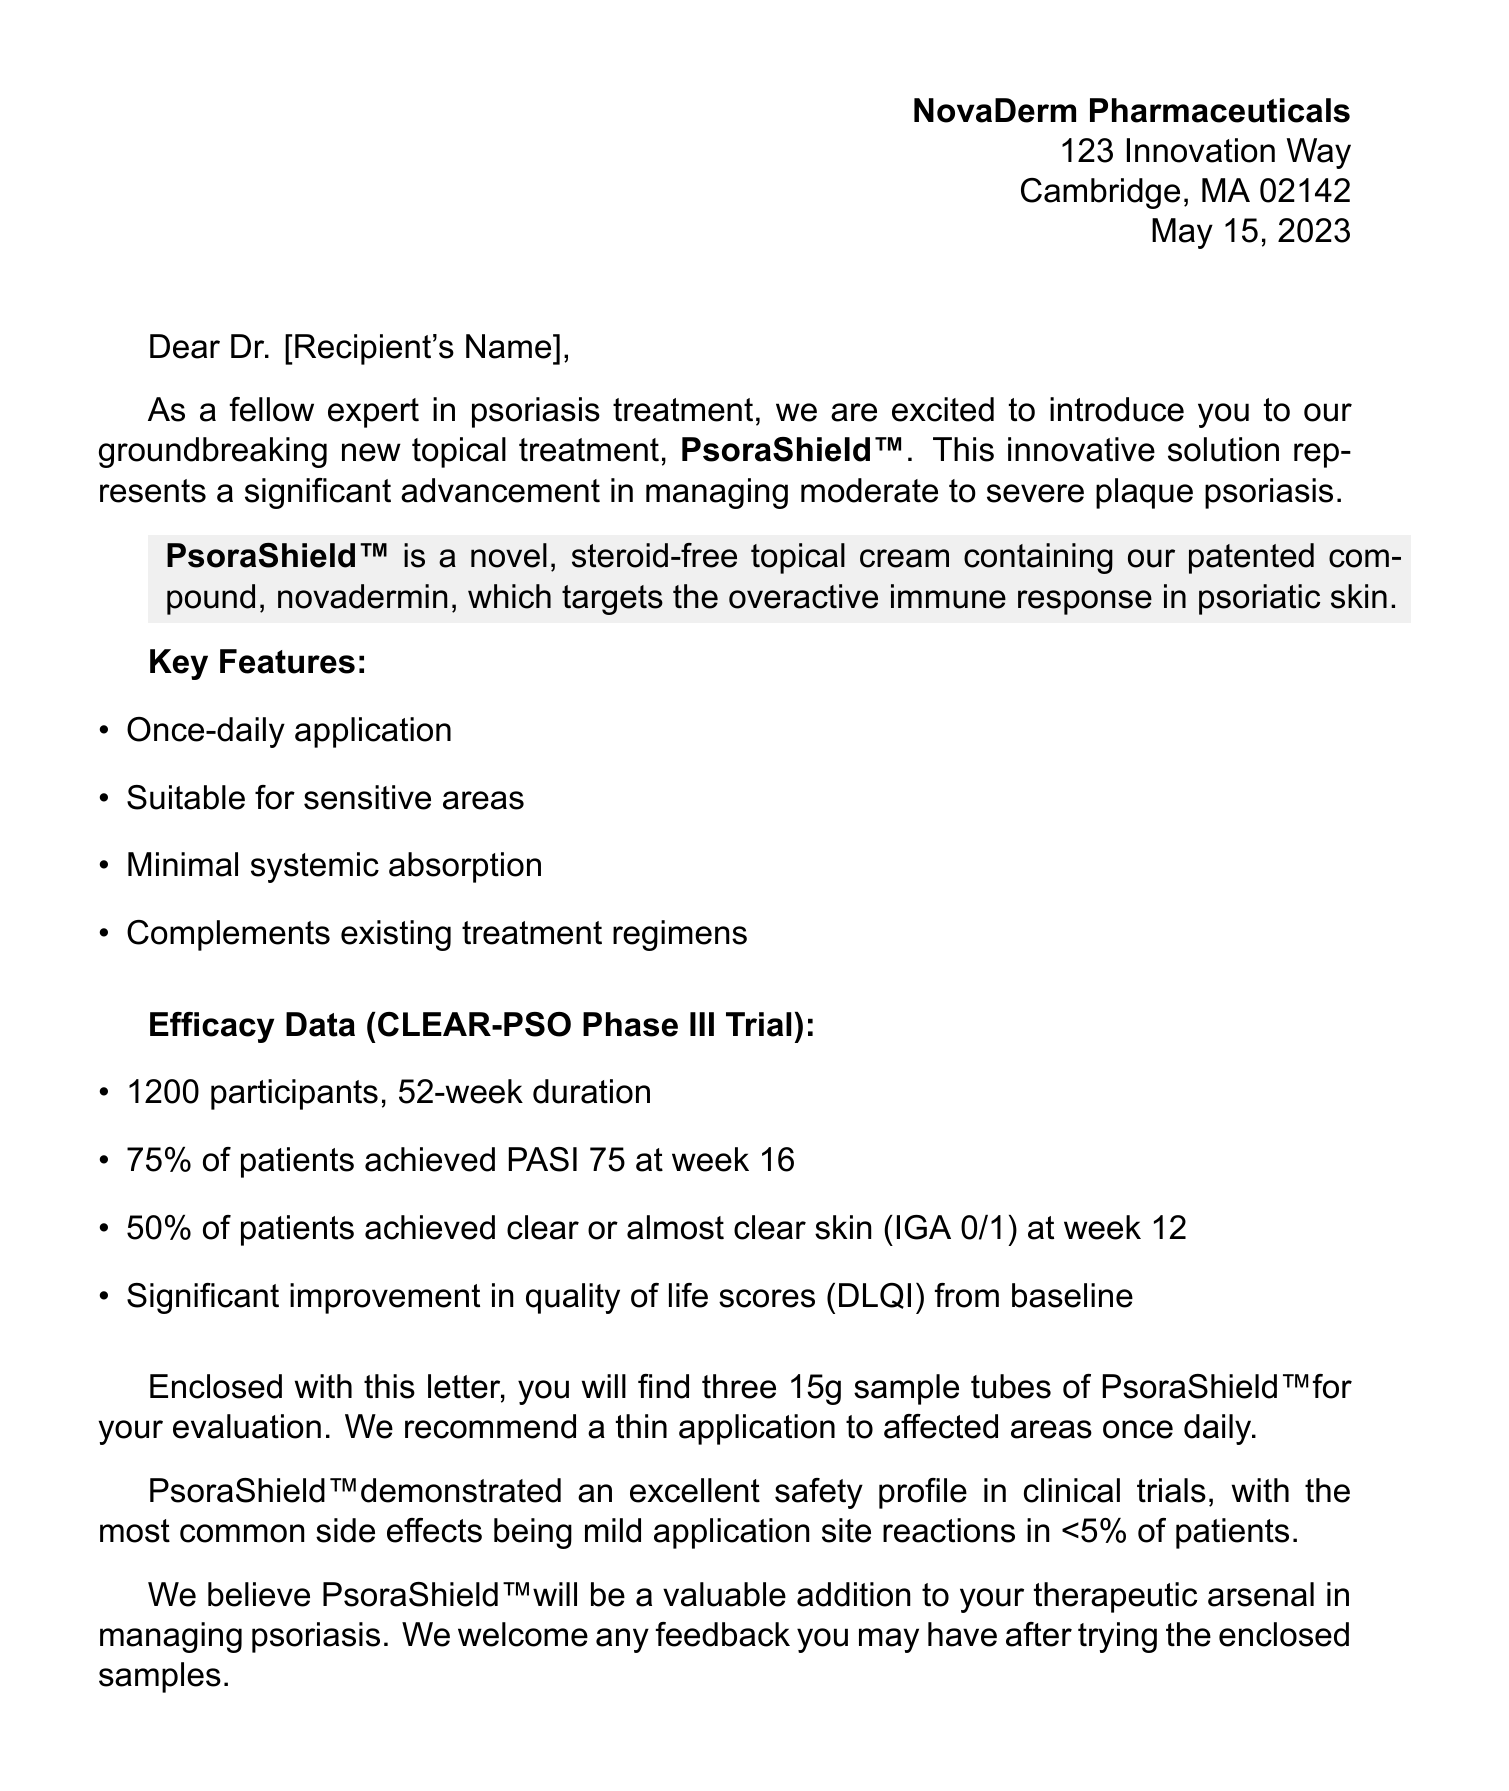what is the name of the new treatment for psoriasis? The name of the new treatment mentioned in the letter is PsoraShield™.
Answer: PsoraShield™ who is the Chief Medical Officer of NovaDerm Pharmaceuticals? According to the document, the Chief Medical Officer is Dr. Emily Chen.
Answer: Dr. Emily Chen how many participants were in the CLEAR-PSO Phase III Trial? The trial involved 1200 participants, as stated in the efficacy data section.
Answer: 1200 what is the recommended application frequency for PsoraShield™? The letter recommends a once-daily application of PsoraShield™.
Answer: once-daily what percentage of patients achieved PASI 75 at week 16? The document states that 75% of patients achieved PASI 75 at week 16.
Answer: 75% what is the duration of the CLEAR-PSO Phase III Trial? The trial duration is mentioned as 52 weeks in the efficacy data.
Answer: 52 weeks what is the most common side effect reported for PsoraShield™? The most common side effect reported is mild application site reactions in less than 5% of patients.
Answer: mild application site reactions how many sample tubes of PsoraShield™ are enclosed with the letter? The letter indicates that there are three 15g sample tubes enclosed for evaluation.
Answer: three 15g sample tubes 